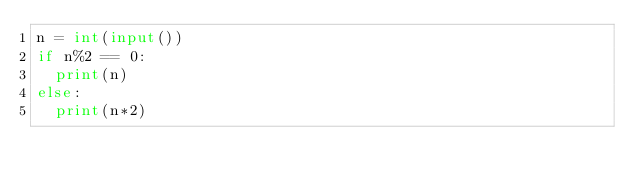<code> <loc_0><loc_0><loc_500><loc_500><_Python_>n = int(input())
if n%2 == 0:
  print(n)
else:
  print(n*2)</code> 